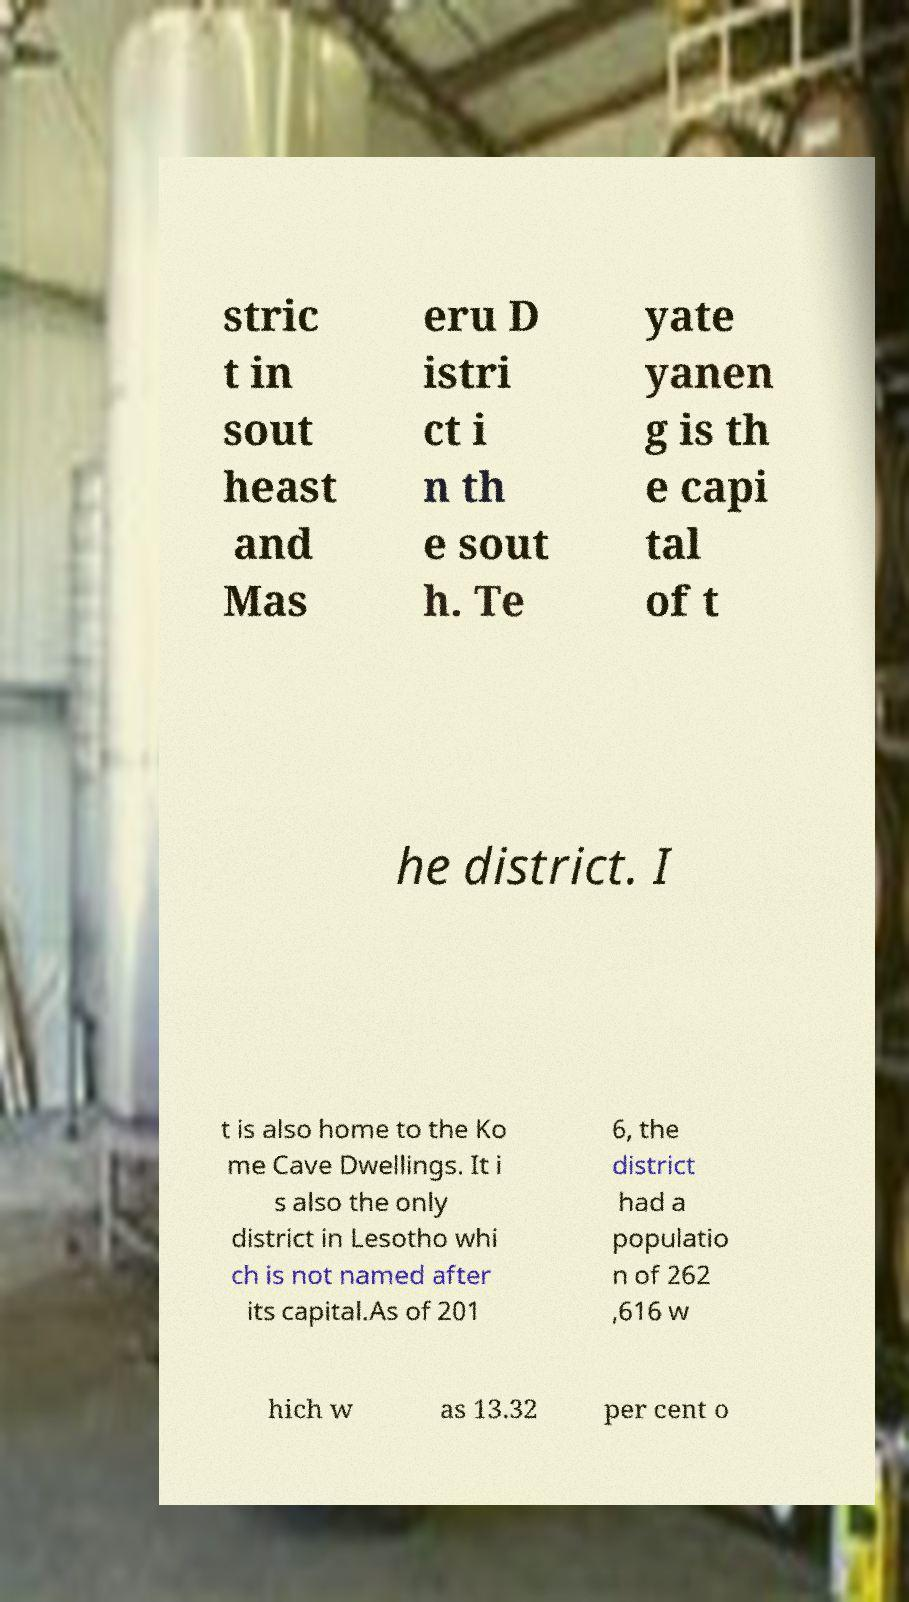Could you assist in decoding the text presented in this image and type it out clearly? stric t in sout heast and Mas eru D istri ct i n th e sout h. Te yate yanen g is th e capi tal of t he district. I t is also home to the Ko me Cave Dwellings. It i s also the only district in Lesotho whi ch is not named after its capital.As of 201 6, the district had a populatio n of 262 ,616 w hich w as 13.32 per cent o 